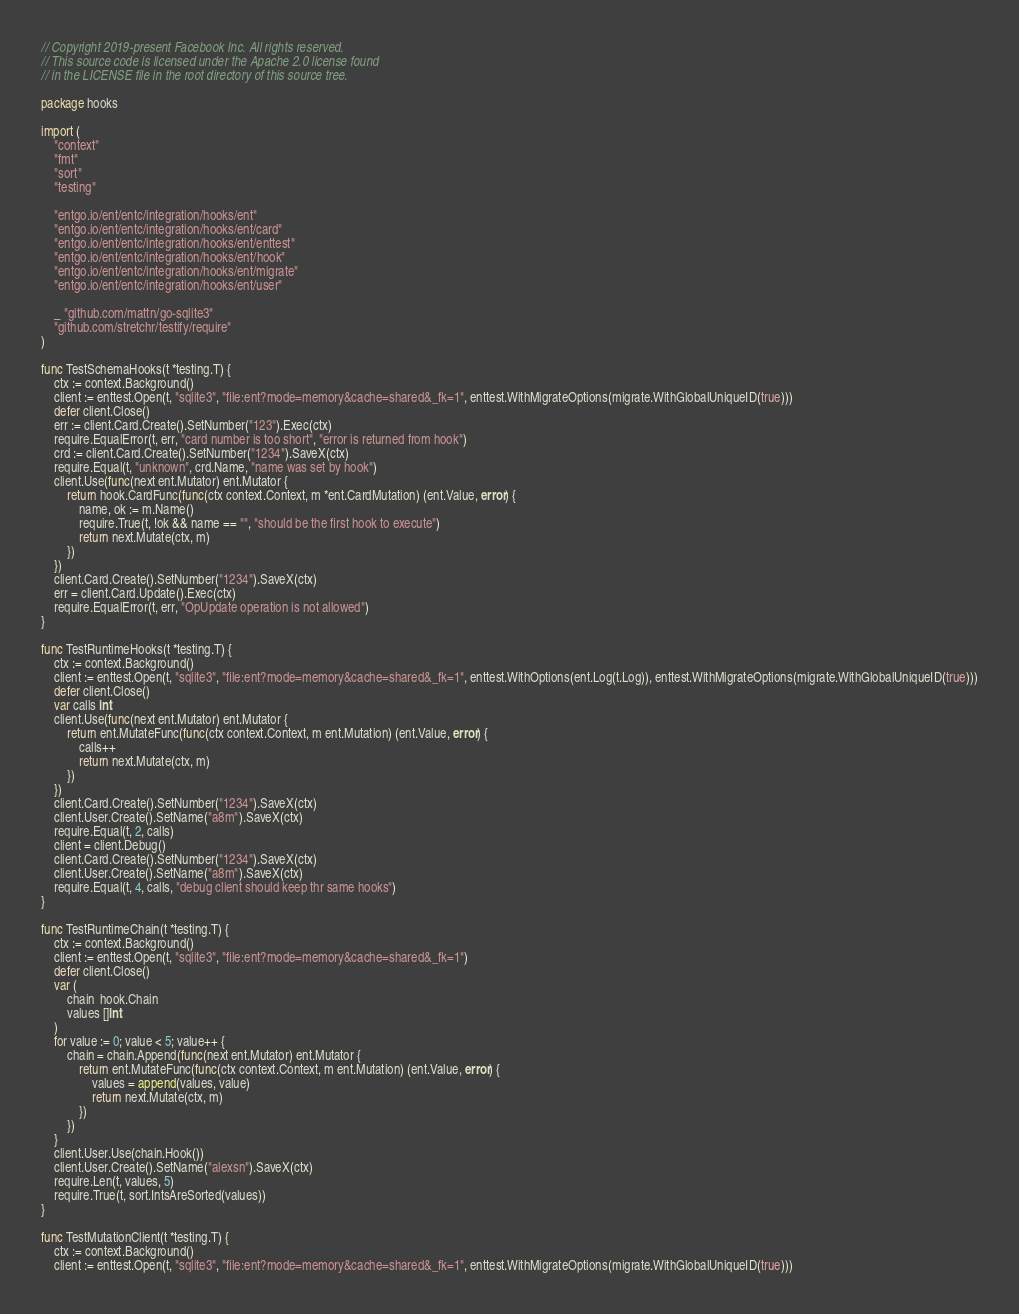<code> <loc_0><loc_0><loc_500><loc_500><_Go_>// Copyright 2019-present Facebook Inc. All rights reserved.
// This source code is licensed under the Apache 2.0 license found
// in the LICENSE file in the root directory of this source tree.

package hooks

import (
	"context"
	"fmt"
	"sort"
	"testing"

	"entgo.io/ent/entc/integration/hooks/ent"
	"entgo.io/ent/entc/integration/hooks/ent/card"
	"entgo.io/ent/entc/integration/hooks/ent/enttest"
	"entgo.io/ent/entc/integration/hooks/ent/hook"
	"entgo.io/ent/entc/integration/hooks/ent/migrate"
	"entgo.io/ent/entc/integration/hooks/ent/user"

	_ "github.com/mattn/go-sqlite3"
	"github.com/stretchr/testify/require"
)

func TestSchemaHooks(t *testing.T) {
	ctx := context.Background()
	client := enttest.Open(t, "sqlite3", "file:ent?mode=memory&cache=shared&_fk=1", enttest.WithMigrateOptions(migrate.WithGlobalUniqueID(true)))
	defer client.Close()
	err := client.Card.Create().SetNumber("123").Exec(ctx)
	require.EqualError(t, err, "card number is too short", "error is returned from hook")
	crd := client.Card.Create().SetNumber("1234").SaveX(ctx)
	require.Equal(t, "unknown", crd.Name, "name was set by hook")
	client.Use(func(next ent.Mutator) ent.Mutator {
		return hook.CardFunc(func(ctx context.Context, m *ent.CardMutation) (ent.Value, error) {
			name, ok := m.Name()
			require.True(t, !ok && name == "", "should be the first hook to execute")
			return next.Mutate(ctx, m)
		})
	})
	client.Card.Create().SetNumber("1234").SaveX(ctx)
	err = client.Card.Update().Exec(ctx)
	require.EqualError(t, err, "OpUpdate operation is not allowed")
}

func TestRuntimeHooks(t *testing.T) {
	ctx := context.Background()
	client := enttest.Open(t, "sqlite3", "file:ent?mode=memory&cache=shared&_fk=1", enttest.WithOptions(ent.Log(t.Log)), enttest.WithMigrateOptions(migrate.WithGlobalUniqueID(true)))
	defer client.Close()
	var calls int
	client.Use(func(next ent.Mutator) ent.Mutator {
		return ent.MutateFunc(func(ctx context.Context, m ent.Mutation) (ent.Value, error) {
			calls++
			return next.Mutate(ctx, m)
		})
	})
	client.Card.Create().SetNumber("1234").SaveX(ctx)
	client.User.Create().SetName("a8m").SaveX(ctx)
	require.Equal(t, 2, calls)
	client = client.Debug()
	client.Card.Create().SetNumber("1234").SaveX(ctx)
	client.User.Create().SetName("a8m").SaveX(ctx)
	require.Equal(t, 4, calls, "debug client should keep thr same hooks")
}

func TestRuntimeChain(t *testing.T) {
	ctx := context.Background()
	client := enttest.Open(t, "sqlite3", "file:ent?mode=memory&cache=shared&_fk=1")
	defer client.Close()
	var (
		chain  hook.Chain
		values []int
	)
	for value := 0; value < 5; value++ {
		chain = chain.Append(func(next ent.Mutator) ent.Mutator {
			return ent.MutateFunc(func(ctx context.Context, m ent.Mutation) (ent.Value, error) {
				values = append(values, value)
				return next.Mutate(ctx, m)
			})
		})
	}
	client.User.Use(chain.Hook())
	client.User.Create().SetName("alexsn").SaveX(ctx)
	require.Len(t, values, 5)
	require.True(t, sort.IntsAreSorted(values))
}

func TestMutationClient(t *testing.T) {
	ctx := context.Background()
	client := enttest.Open(t, "sqlite3", "file:ent?mode=memory&cache=shared&_fk=1", enttest.WithMigrateOptions(migrate.WithGlobalUniqueID(true)))</code> 